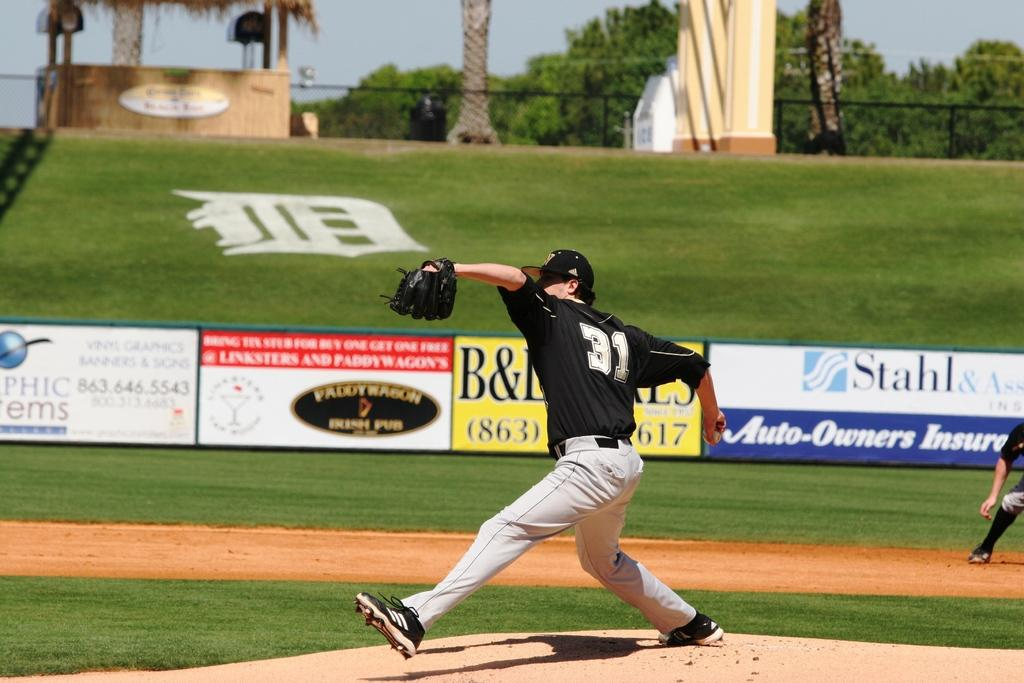<image>
Provide a brief description of the given image. A baseball team's number 31 player winds up for a pitch. 